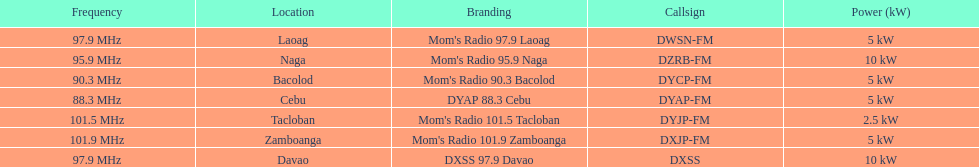How many kw was the radio in davao? 10 kW. Can you parse all the data within this table? {'header': ['Frequency', 'Location', 'Branding', 'Callsign', 'Power (kW)'], 'rows': [['97.9\xa0MHz', 'Laoag', "Mom's Radio 97.9 Laoag", 'DWSN-FM', '5\xa0kW'], ['95.9\xa0MHz', 'Naga', "Mom's Radio 95.9 Naga", 'DZRB-FM', '10\xa0kW'], ['90.3\xa0MHz', 'Bacolod', "Mom's Radio 90.3 Bacolod", 'DYCP-FM', '5\xa0kW'], ['88.3\xa0MHz', 'Cebu', 'DYAP 88.3 Cebu', 'DYAP-FM', '5\xa0kW'], ['101.5\xa0MHz', 'Tacloban', "Mom's Radio 101.5 Tacloban", 'DYJP-FM', '2.5\xa0kW'], ['101.9\xa0MHz', 'Zamboanga', "Mom's Radio 101.9 Zamboanga", 'DXJP-FM', '5\xa0kW'], ['97.9\xa0MHz', 'Davao', 'DXSS 97.9 Davao', 'DXSS', '10\xa0kW']]} 